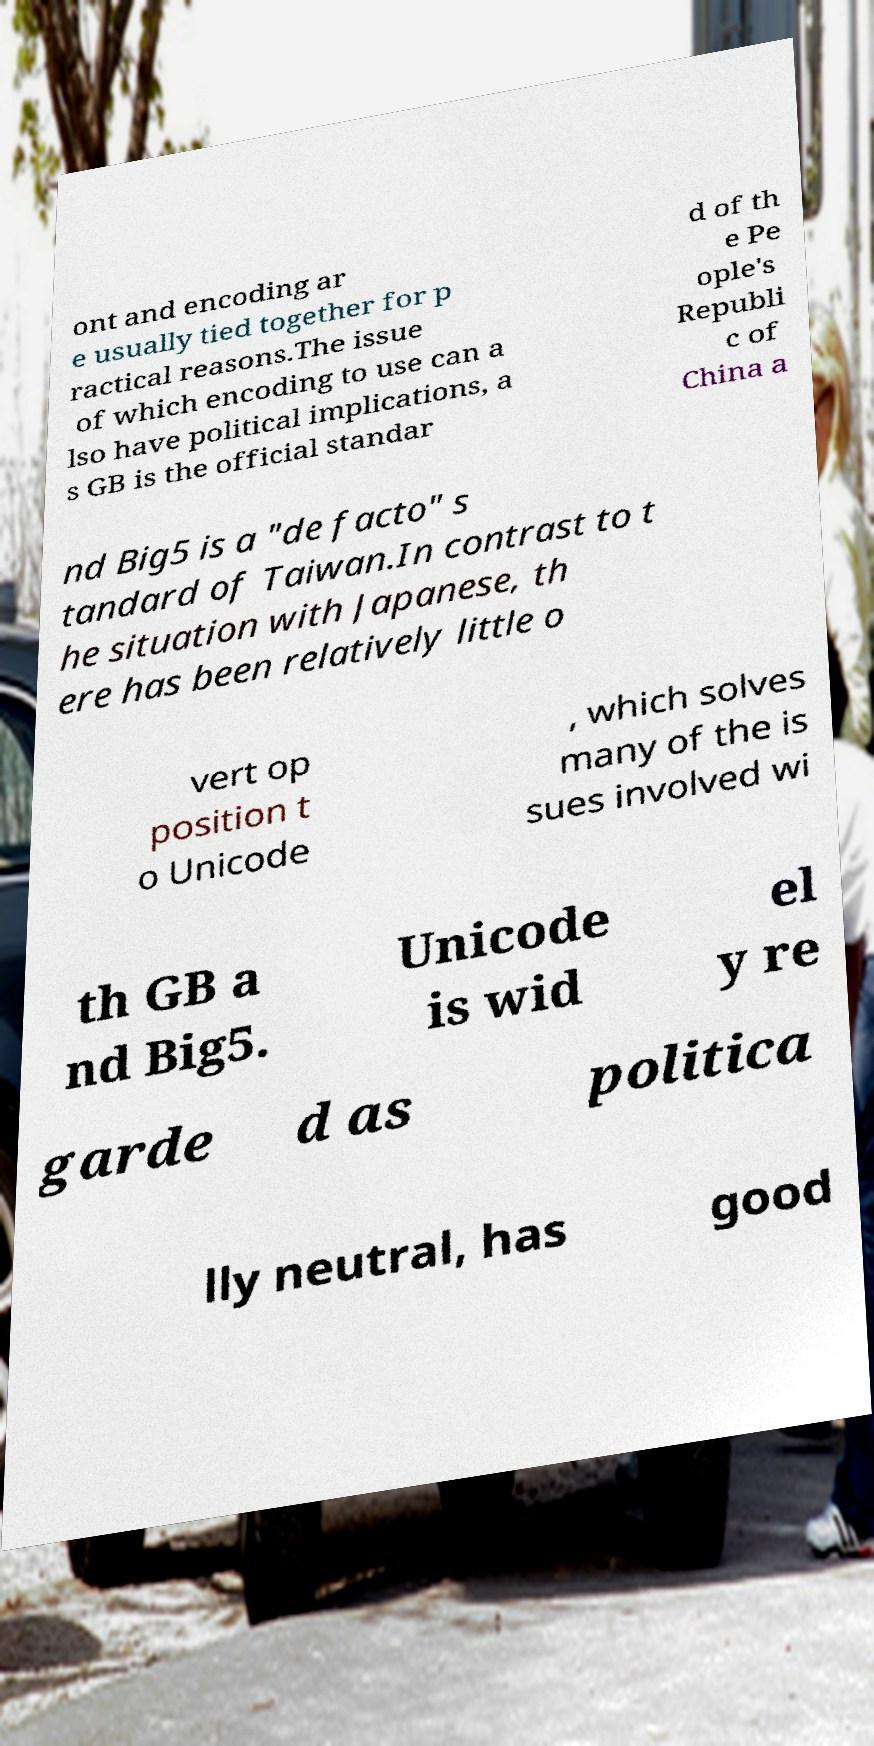There's text embedded in this image that I need extracted. Can you transcribe it verbatim? ont and encoding ar e usually tied together for p ractical reasons.The issue of which encoding to use can a lso have political implications, a s GB is the official standar d of th e Pe ople's Republi c of China a nd Big5 is a "de facto" s tandard of Taiwan.In contrast to t he situation with Japanese, th ere has been relatively little o vert op position t o Unicode , which solves many of the is sues involved wi th GB a nd Big5. Unicode is wid el y re garde d as politica lly neutral, has good 